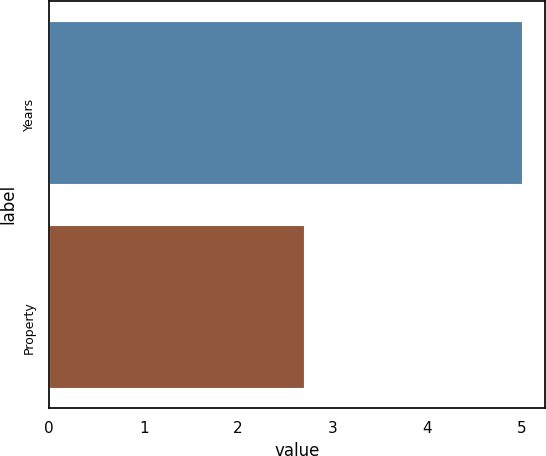<chart> <loc_0><loc_0><loc_500><loc_500><bar_chart><fcel>Years<fcel>Property<nl><fcel>5<fcel>2.7<nl></chart> 